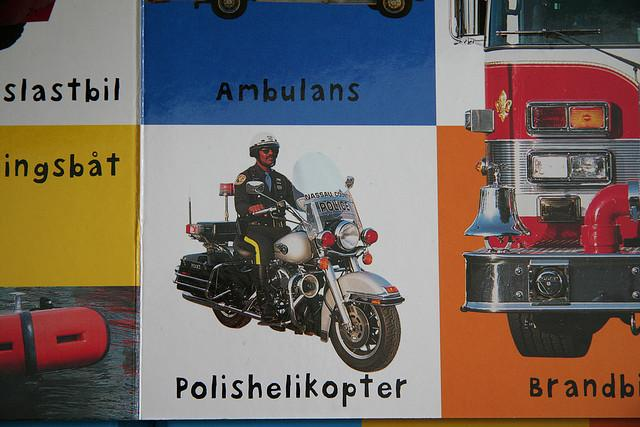What is the profession of the man on a motorcycle? police officer 